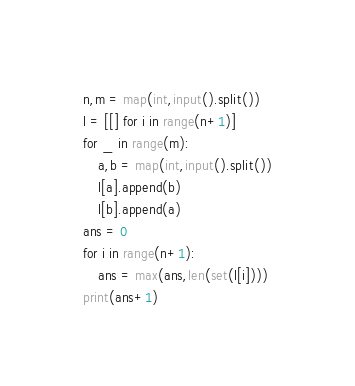Convert code to text. <code><loc_0><loc_0><loc_500><loc_500><_Python_>n,m = map(int,input().split())
l = [[] for i in range(n+1)]
for _ in range(m):
    a,b = map(int,input().split())
    l[a].append(b)
    l[b].append(a)
ans = 0
for i in range(n+1):
    ans = max(ans,len(set(l[i])))
print(ans+1)</code> 